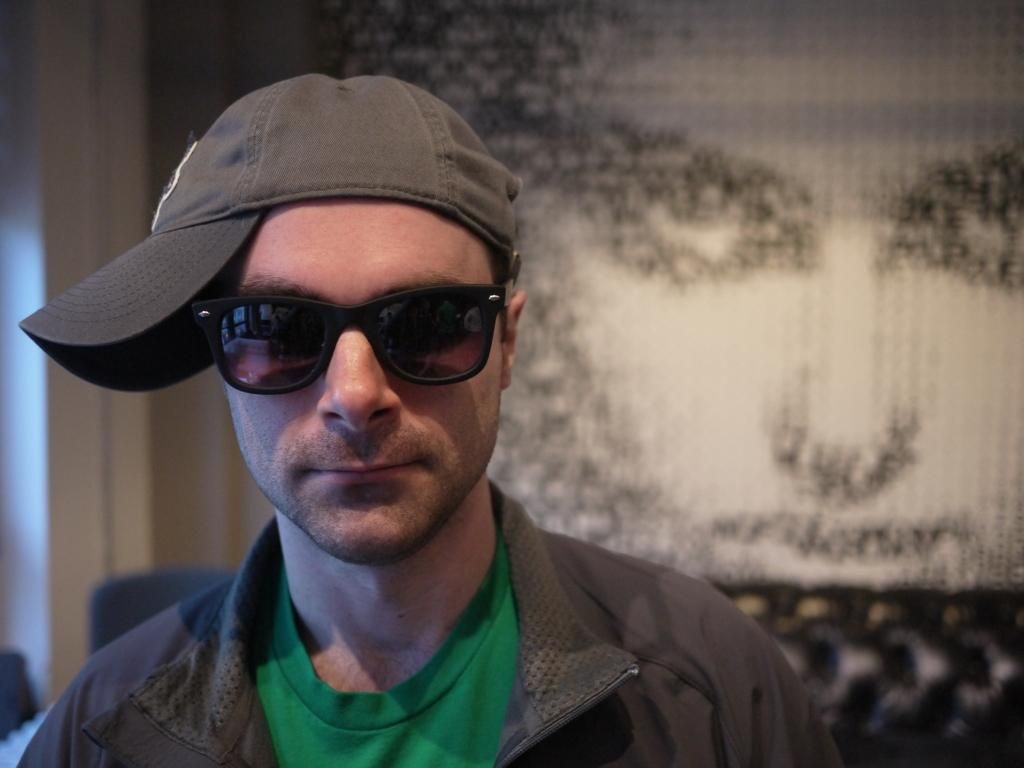What can be seen in the image? There is a person in the image. Can you describe the person's appearance? The person is wearing spectacles and a cap. What is visible in the background of the image? There is a painting in the background of the image. How many goldfish are swimming in the person's cap in the image? There are no goldfish present in the image, and the person's cap does not contain any water for fish to swim in. 